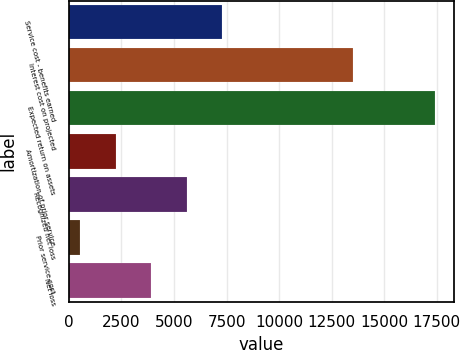<chart> <loc_0><loc_0><loc_500><loc_500><bar_chart><fcel>Service cost - benefits earned<fcel>Interest cost on projected<fcel>Expected return on assets<fcel>Amortization of prior service<fcel>Recognized net loss<fcel>Prior service cost<fcel>Net loss<nl><fcel>7291.6<fcel>13502<fcel>17434<fcel>2220.4<fcel>5601.2<fcel>530<fcel>3910.8<nl></chart> 